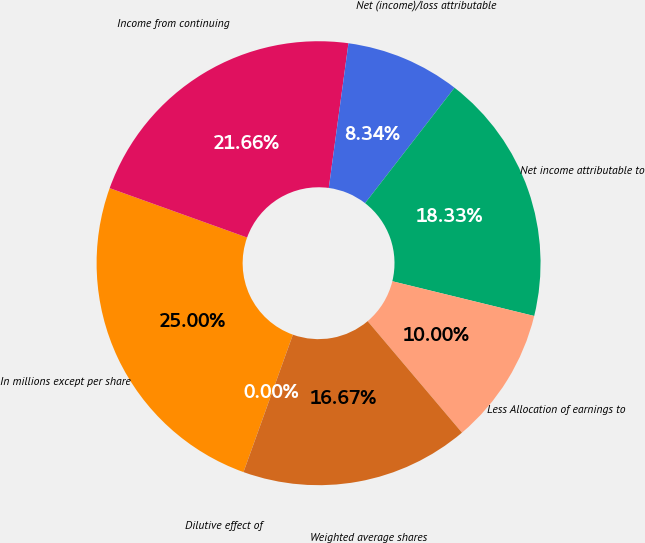Convert chart. <chart><loc_0><loc_0><loc_500><loc_500><pie_chart><fcel>In millions except per share<fcel>Income from continuing<fcel>Net (income)/loss attributable<fcel>Net income attributable to<fcel>Less Allocation of earnings to<fcel>Weighted average shares<fcel>Dilutive effect of<nl><fcel>25.0%<fcel>21.66%<fcel>8.34%<fcel>18.33%<fcel>10.0%<fcel>16.67%<fcel>0.0%<nl></chart> 